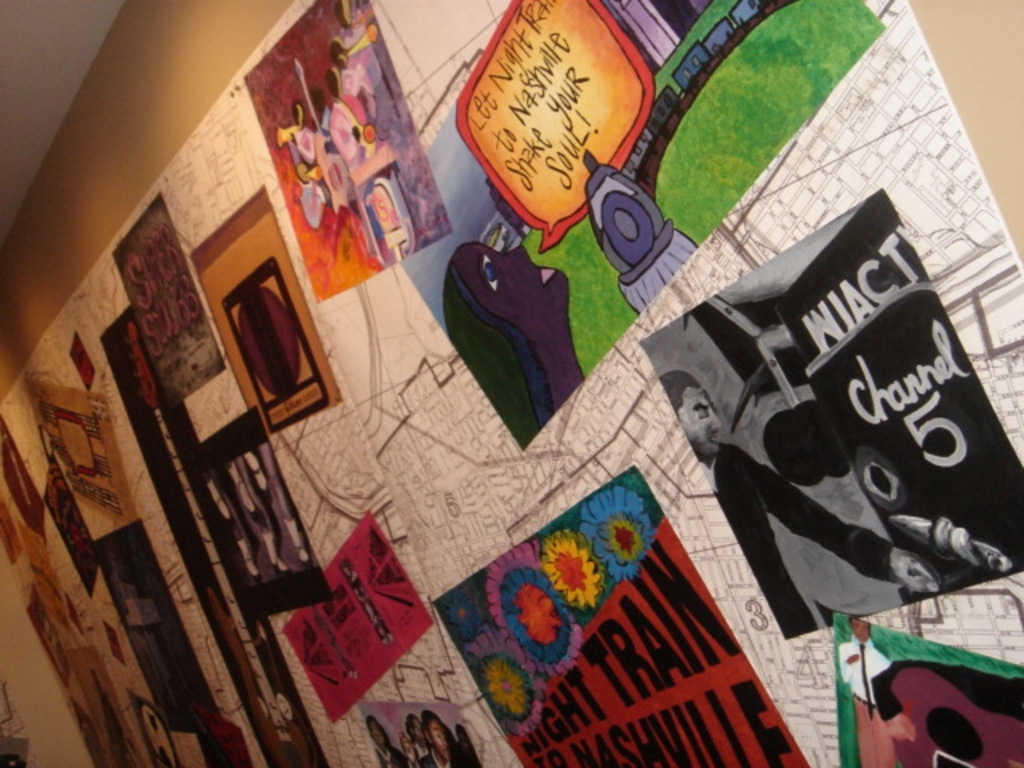Can you tell more about the significance of the 'Night Train to Nashville' artwork? The 'Night Train to Nashville' poster likely celebrates Nashville's rich music heritage, particularly its vibrant nightlife and historic role in the evolution of various music genres, symbolizing a journey through the soulful musical landscape of this iconic city. How does this representation contribute to the overall atmosphere of the space? This piece adds a historical and musical context to the space, likely designed to inspire visitors and create a dialogue between Nashville's past and present music scenes, thus enriching the artistic and cultural ambiance of the environment. 